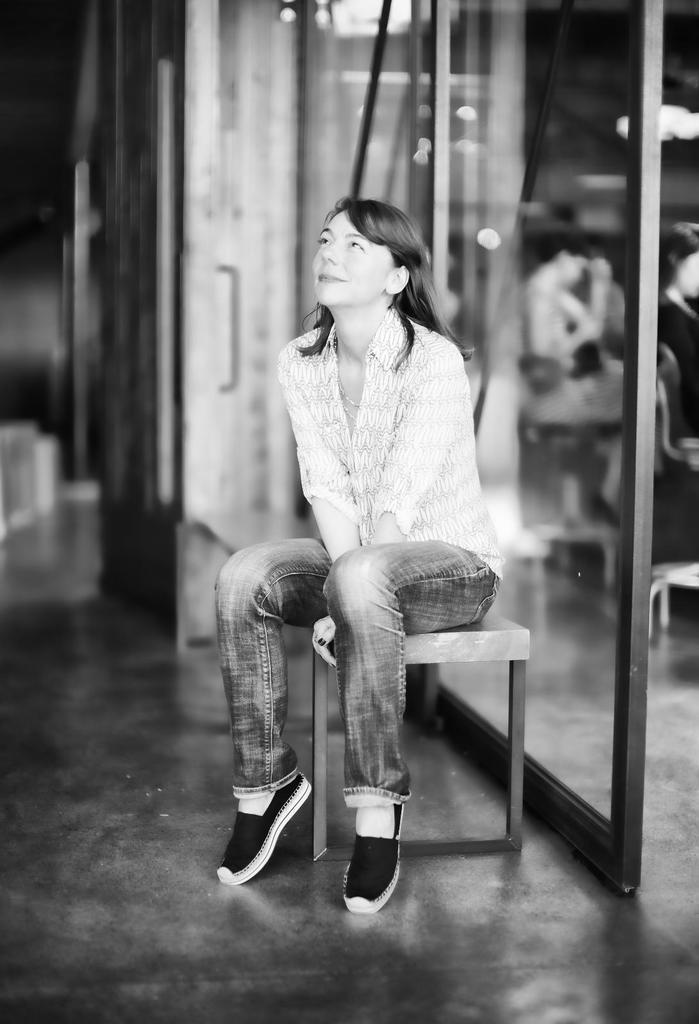Describe this image in one or two sentences. Here we can see a woman sitting on a stool, wearing black shoes and behind her we can see people sitting on chairs inside 